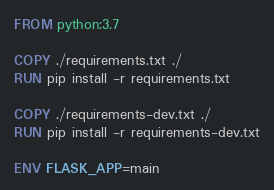Convert code to text. <code><loc_0><loc_0><loc_500><loc_500><_Dockerfile_>FROM python:3.7

COPY ./requirements.txt ./
RUN pip install -r requirements.txt

COPY ./requirements-dev.txt ./
RUN pip install -r requirements-dev.txt

ENV FLASK_APP=main
</code> 